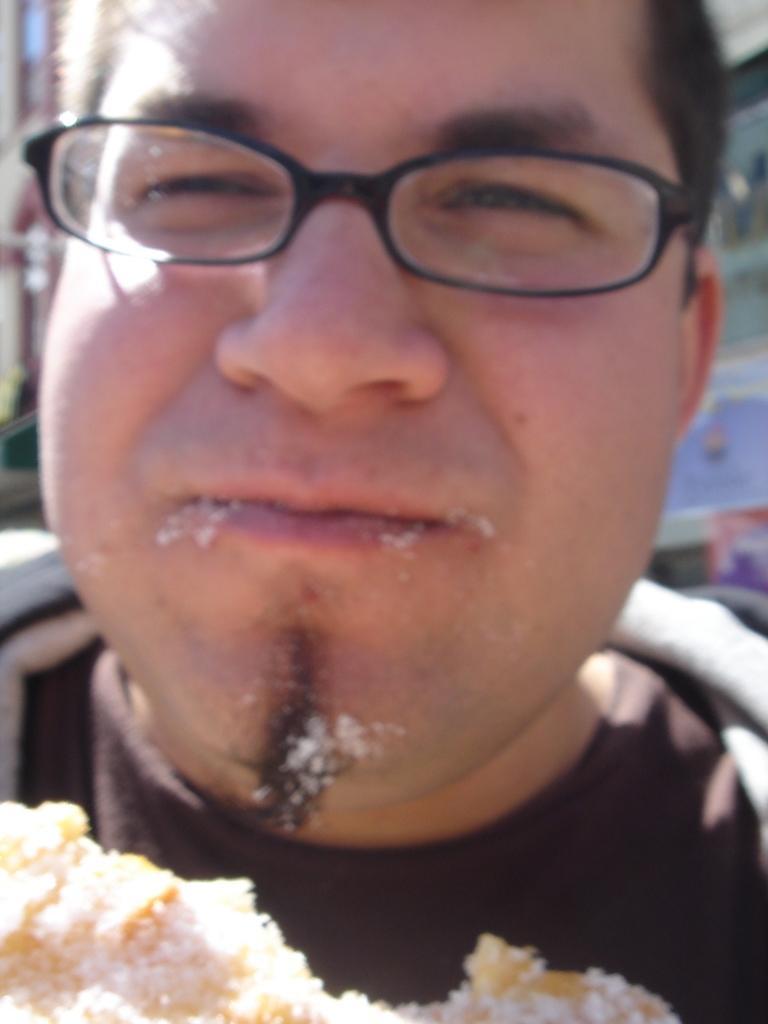Who is present in the image? There is a man in the image. What can be observed about the man's appearance? The man is wearing spectacles. What is located near the man in the image? There is food in front of the man. Can you describe the background of the image? The background of the image is blurry. What type of sand can be seen in the shape of a stick in the image? There is no sand or stick present in the image. 